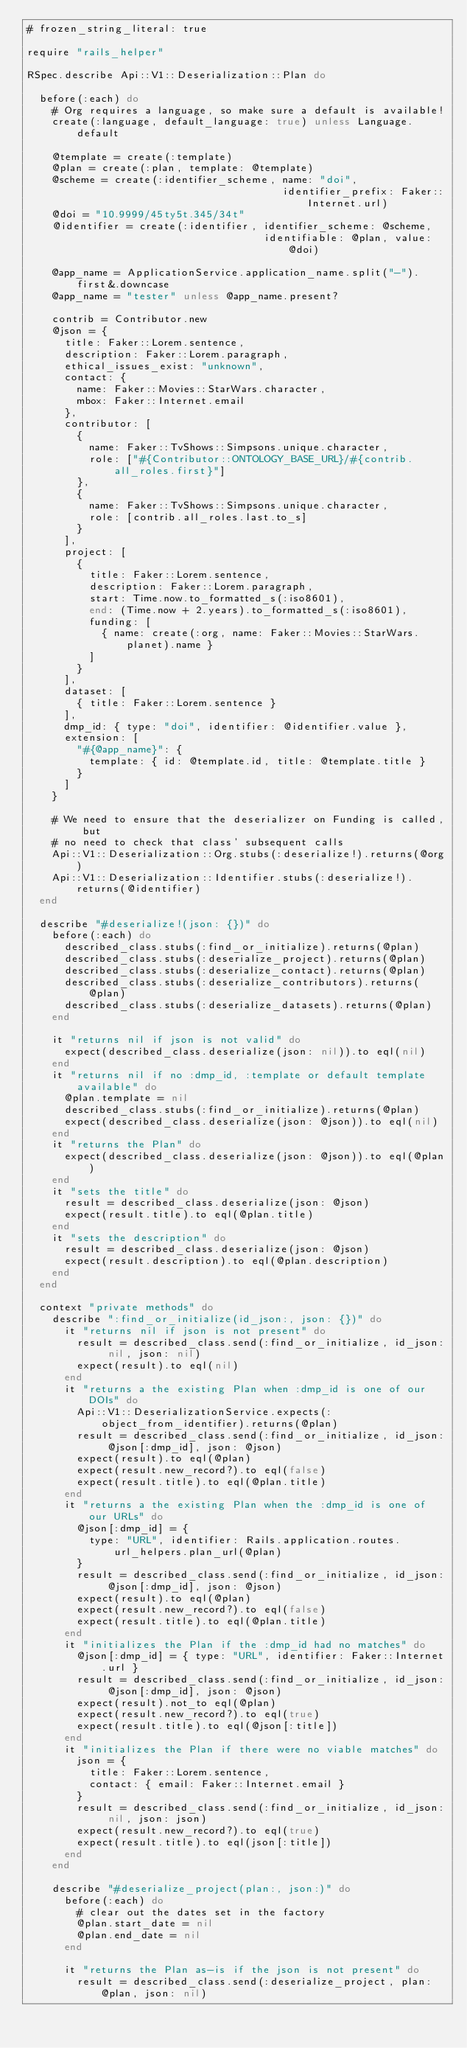Convert code to text. <code><loc_0><loc_0><loc_500><loc_500><_Ruby_># frozen_string_literal: true

require "rails_helper"

RSpec.describe Api::V1::Deserialization::Plan do

  before(:each) do
    # Org requires a language, so make sure a default is available!
    create(:language, default_language: true) unless Language.default

    @template = create(:template)
    @plan = create(:plan, template: @template)
    @scheme = create(:identifier_scheme, name: "doi",
                                         identifier_prefix: Faker::Internet.url)
    @doi = "10.9999/45ty5t.345/34t"
    @identifier = create(:identifier, identifier_scheme: @scheme,
                                      identifiable: @plan, value: @doi)

    @app_name = ApplicationService.application_name.split("-").first&.downcase
    @app_name = "tester" unless @app_name.present?

    contrib = Contributor.new
    @json = {
      title: Faker::Lorem.sentence,
      description: Faker::Lorem.paragraph,
      ethical_issues_exist: "unknown",
      contact: {
        name: Faker::Movies::StarWars.character,
        mbox: Faker::Internet.email
      },
      contributor: [
        {
          name: Faker::TvShows::Simpsons.unique.character,
          role: ["#{Contributor::ONTOLOGY_BASE_URL}/#{contrib.all_roles.first}"]
        },
        {
          name: Faker::TvShows::Simpsons.unique.character,
          role: [contrib.all_roles.last.to_s]
        }
      ],
      project: [
        {
          title: Faker::Lorem.sentence,
          description: Faker::Lorem.paragraph,
          start: Time.now.to_formatted_s(:iso8601),
          end: (Time.now + 2.years).to_formatted_s(:iso8601),
          funding: [
            { name: create(:org, name: Faker::Movies::StarWars.planet).name }
          ]
        }
      ],
      dataset: [
        { title: Faker::Lorem.sentence }
      ],
      dmp_id: { type: "doi", identifier: @identifier.value },
      extension: [
        "#{@app_name}": {
          template: { id: @template.id, title: @template.title }
        }
      ]
    }

    # We need to ensure that the deserializer on Funding is called, but
    # no need to check that class' subsequent calls
    Api::V1::Deserialization::Org.stubs(:deserialize!).returns(@org)
    Api::V1::Deserialization::Identifier.stubs(:deserialize!).returns(@identifier)
  end

  describe "#deserialize!(json: {})" do
    before(:each) do
      described_class.stubs(:find_or_initialize).returns(@plan)
      described_class.stubs(:deserialize_project).returns(@plan)
      described_class.stubs(:deserialize_contact).returns(@plan)
      described_class.stubs(:deserialize_contributors).returns(@plan)
      described_class.stubs(:deserialize_datasets).returns(@plan)
    end

    it "returns nil if json is not valid" do
      expect(described_class.deserialize(json: nil)).to eql(nil)
    end
    it "returns nil if no :dmp_id, :template or default template available" do
      @plan.template = nil
      described_class.stubs(:find_or_initialize).returns(@plan)
      expect(described_class.deserialize(json: @json)).to eql(nil)
    end
    it "returns the Plan" do
      expect(described_class.deserialize(json: @json)).to eql(@plan)
    end
    it "sets the title" do
      result = described_class.deserialize(json: @json)
      expect(result.title).to eql(@plan.title)
    end
    it "sets the description" do
      result = described_class.deserialize(json: @json)
      expect(result.description).to eql(@plan.description)
    end
  end

  context "private methods" do
    describe ":find_or_initialize(id_json:, json: {})" do
      it "returns nil if json is not present" do
        result = described_class.send(:find_or_initialize, id_json: nil, json: nil)
        expect(result).to eql(nil)
      end
      it "returns a the existing Plan when :dmp_id is one of our DOIs" do
        Api::V1::DeserializationService.expects(:object_from_identifier).returns(@plan)
        result = described_class.send(:find_or_initialize, id_json: @json[:dmp_id], json: @json)
        expect(result).to eql(@plan)
        expect(result.new_record?).to eql(false)
        expect(result.title).to eql(@plan.title)
      end
      it "returns a the existing Plan when the :dmp_id is one of our URLs" do
        @json[:dmp_id] = {
          type: "URL", identifier: Rails.application.routes.url_helpers.plan_url(@plan)
        }
        result = described_class.send(:find_or_initialize, id_json: @json[:dmp_id], json: @json)
        expect(result).to eql(@plan)
        expect(result.new_record?).to eql(false)
        expect(result.title).to eql(@plan.title)
      end
      it "initializes the Plan if the :dmp_id had no matches" do
        @json[:dmp_id] = { type: "URL", identifier: Faker::Internet.url }
        result = described_class.send(:find_or_initialize, id_json: @json[:dmp_id], json: @json)
        expect(result).not_to eql(@plan)
        expect(result.new_record?).to eql(true)
        expect(result.title).to eql(@json[:title])
      end
      it "initializes the Plan if there were no viable matches" do
        json = {
          title: Faker::Lorem.sentence,
          contact: { email: Faker::Internet.email }
        }
        result = described_class.send(:find_or_initialize, id_json: nil, json: json)
        expect(result.new_record?).to eql(true)
        expect(result.title).to eql(json[:title])
      end
    end

    describe "#deserialize_project(plan:, json:)" do
      before(:each) do
        # clear out the dates set in the factory
        @plan.start_date = nil
        @plan.end_date = nil
      end

      it "returns the Plan as-is if the json is not present" do
        result = described_class.send(:deserialize_project, plan: @plan, json: nil)</code> 